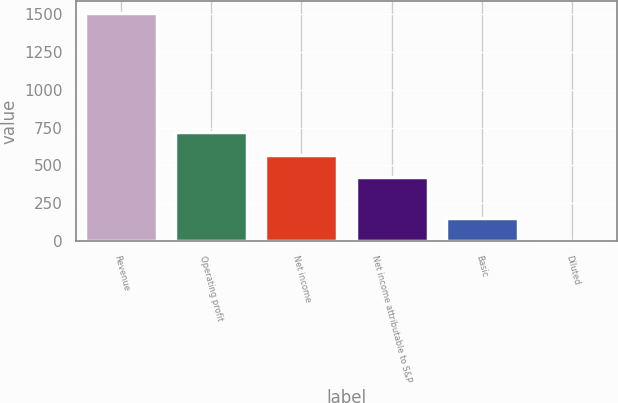Convert chart. <chart><loc_0><loc_0><loc_500><loc_500><bar_chart><fcel>Revenue<fcel>Operating profit<fcel>Net income<fcel>Net income attributable to S&P<fcel>Basic<fcel>Diluted<nl><fcel>1509<fcel>722.48<fcel>571.74<fcel>421<fcel>152.36<fcel>1.62<nl></chart> 